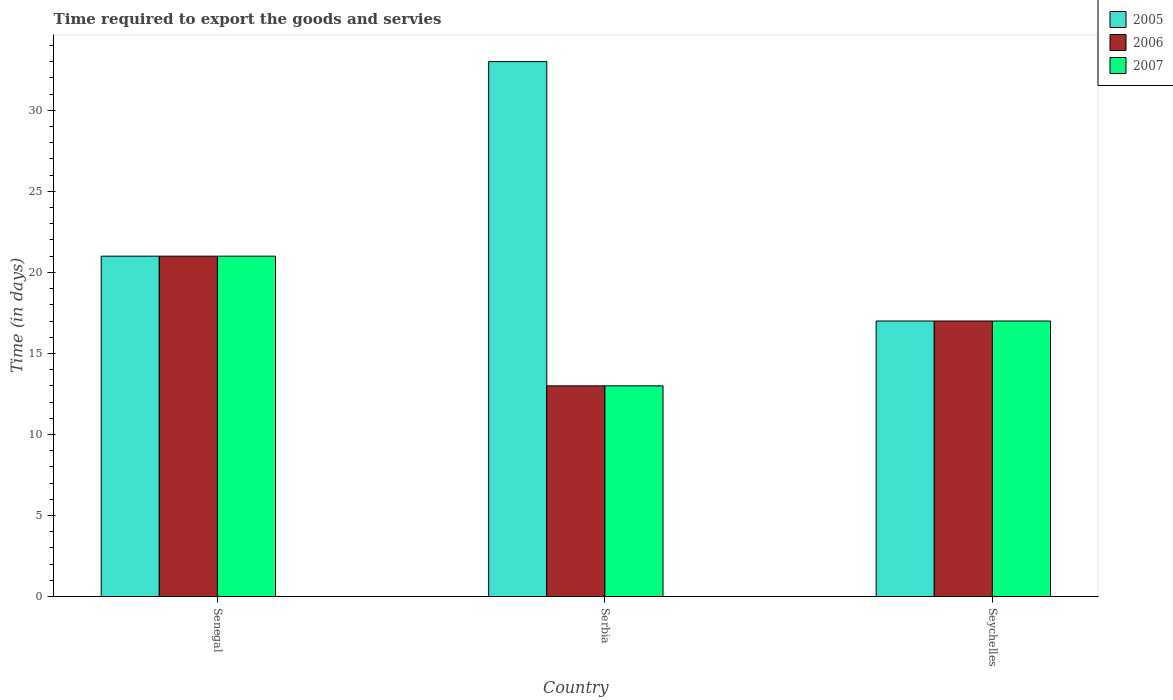Are the number of bars per tick equal to the number of legend labels?
Provide a succinct answer. Yes. Are the number of bars on each tick of the X-axis equal?
Provide a short and direct response. Yes. What is the label of the 2nd group of bars from the left?
Your answer should be very brief. Serbia. In how many cases, is the number of bars for a given country not equal to the number of legend labels?
Make the answer very short. 0. Across all countries, what is the maximum number of days required to export the goods and services in 2006?
Offer a very short reply. 21. In which country was the number of days required to export the goods and services in 2005 maximum?
Provide a short and direct response. Serbia. In which country was the number of days required to export the goods and services in 2006 minimum?
Provide a succinct answer. Serbia. What is the difference between the number of days required to export the goods and services in 2005 in Serbia and the number of days required to export the goods and services in 2006 in Seychelles?
Your response must be concise. 16. What is the average number of days required to export the goods and services in 2007 per country?
Provide a succinct answer. 17. What is the ratio of the number of days required to export the goods and services in 2007 in Senegal to that in Serbia?
Your response must be concise. 1.62. In how many countries, is the number of days required to export the goods and services in 2005 greater than the average number of days required to export the goods and services in 2005 taken over all countries?
Your answer should be very brief. 1. Is the sum of the number of days required to export the goods and services in 2006 in Serbia and Seychelles greater than the maximum number of days required to export the goods and services in 2007 across all countries?
Your response must be concise. Yes. What does the 1st bar from the left in Seychelles represents?
Your answer should be very brief. 2005. What does the 2nd bar from the right in Senegal represents?
Give a very brief answer. 2006. Is it the case that in every country, the sum of the number of days required to export the goods and services in 2007 and number of days required to export the goods and services in 2006 is greater than the number of days required to export the goods and services in 2005?
Give a very brief answer. No. How many bars are there?
Offer a very short reply. 9. Are all the bars in the graph horizontal?
Offer a very short reply. No. What is the difference between two consecutive major ticks on the Y-axis?
Keep it short and to the point. 5. Where does the legend appear in the graph?
Make the answer very short. Top right. How are the legend labels stacked?
Offer a terse response. Vertical. What is the title of the graph?
Ensure brevity in your answer.  Time required to export the goods and servies. Does "1974" appear as one of the legend labels in the graph?
Your answer should be very brief. No. What is the label or title of the Y-axis?
Provide a succinct answer. Time (in days). What is the Time (in days) of 2006 in Senegal?
Your answer should be very brief. 21. What is the Time (in days) in 2007 in Senegal?
Your response must be concise. 21. What is the Time (in days) in 2007 in Serbia?
Offer a terse response. 13. What is the Time (in days) of 2006 in Seychelles?
Make the answer very short. 17. What is the Time (in days) of 2007 in Seychelles?
Provide a succinct answer. 17. Across all countries, what is the maximum Time (in days) in 2005?
Your response must be concise. 33. Across all countries, what is the maximum Time (in days) of 2006?
Provide a short and direct response. 21. Across all countries, what is the maximum Time (in days) of 2007?
Offer a very short reply. 21. Across all countries, what is the minimum Time (in days) of 2005?
Give a very brief answer. 17. Across all countries, what is the minimum Time (in days) in 2007?
Provide a succinct answer. 13. What is the total Time (in days) in 2005 in the graph?
Your answer should be very brief. 71. What is the difference between the Time (in days) of 2005 in Senegal and that in Serbia?
Ensure brevity in your answer.  -12. What is the difference between the Time (in days) of 2007 in Senegal and that in Serbia?
Ensure brevity in your answer.  8. What is the difference between the Time (in days) in 2005 in Senegal and that in Seychelles?
Provide a succinct answer. 4. What is the difference between the Time (in days) of 2006 in Senegal and that in Seychelles?
Make the answer very short. 4. What is the difference between the Time (in days) in 2007 in Serbia and that in Seychelles?
Make the answer very short. -4. What is the difference between the Time (in days) in 2005 in Senegal and the Time (in days) in 2006 in Serbia?
Your response must be concise. 8. What is the difference between the Time (in days) of 2005 in Senegal and the Time (in days) of 2007 in Seychelles?
Your response must be concise. 4. What is the difference between the Time (in days) in 2005 in Serbia and the Time (in days) in 2006 in Seychelles?
Offer a very short reply. 16. What is the difference between the Time (in days) in 2005 in Serbia and the Time (in days) in 2007 in Seychelles?
Provide a short and direct response. 16. What is the average Time (in days) of 2005 per country?
Ensure brevity in your answer.  23.67. What is the difference between the Time (in days) in 2005 and Time (in days) in 2006 in Senegal?
Give a very brief answer. 0. What is the difference between the Time (in days) in 2005 and Time (in days) in 2007 in Senegal?
Provide a succinct answer. 0. What is the difference between the Time (in days) of 2005 and Time (in days) of 2007 in Serbia?
Provide a succinct answer. 20. What is the ratio of the Time (in days) of 2005 in Senegal to that in Serbia?
Ensure brevity in your answer.  0.64. What is the ratio of the Time (in days) of 2006 in Senegal to that in Serbia?
Ensure brevity in your answer.  1.62. What is the ratio of the Time (in days) in 2007 in Senegal to that in Serbia?
Ensure brevity in your answer.  1.62. What is the ratio of the Time (in days) of 2005 in Senegal to that in Seychelles?
Offer a very short reply. 1.24. What is the ratio of the Time (in days) in 2006 in Senegal to that in Seychelles?
Your answer should be very brief. 1.24. What is the ratio of the Time (in days) in 2007 in Senegal to that in Seychelles?
Offer a very short reply. 1.24. What is the ratio of the Time (in days) in 2005 in Serbia to that in Seychelles?
Offer a terse response. 1.94. What is the ratio of the Time (in days) in 2006 in Serbia to that in Seychelles?
Provide a short and direct response. 0.76. What is the ratio of the Time (in days) of 2007 in Serbia to that in Seychelles?
Offer a very short reply. 0.76. What is the difference between the highest and the second highest Time (in days) of 2006?
Provide a succinct answer. 4. What is the difference between the highest and the second highest Time (in days) in 2007?
Your answer should be very brief. 4. What is the difference between the highest and the lowest Time (in days) of 2005?
Provide a short and direct response. 16. What is the difference between the highest and the lowest Time (in days) in 2006?
Give a very brief answer. 8. What is the difference between the highest and the lowest Time (in days) of 2007?
Offer a terse response. 8. 